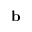<formula> <loc_0><loc_0><loc_500><loc_500>{ \mathbf b }</formula> 